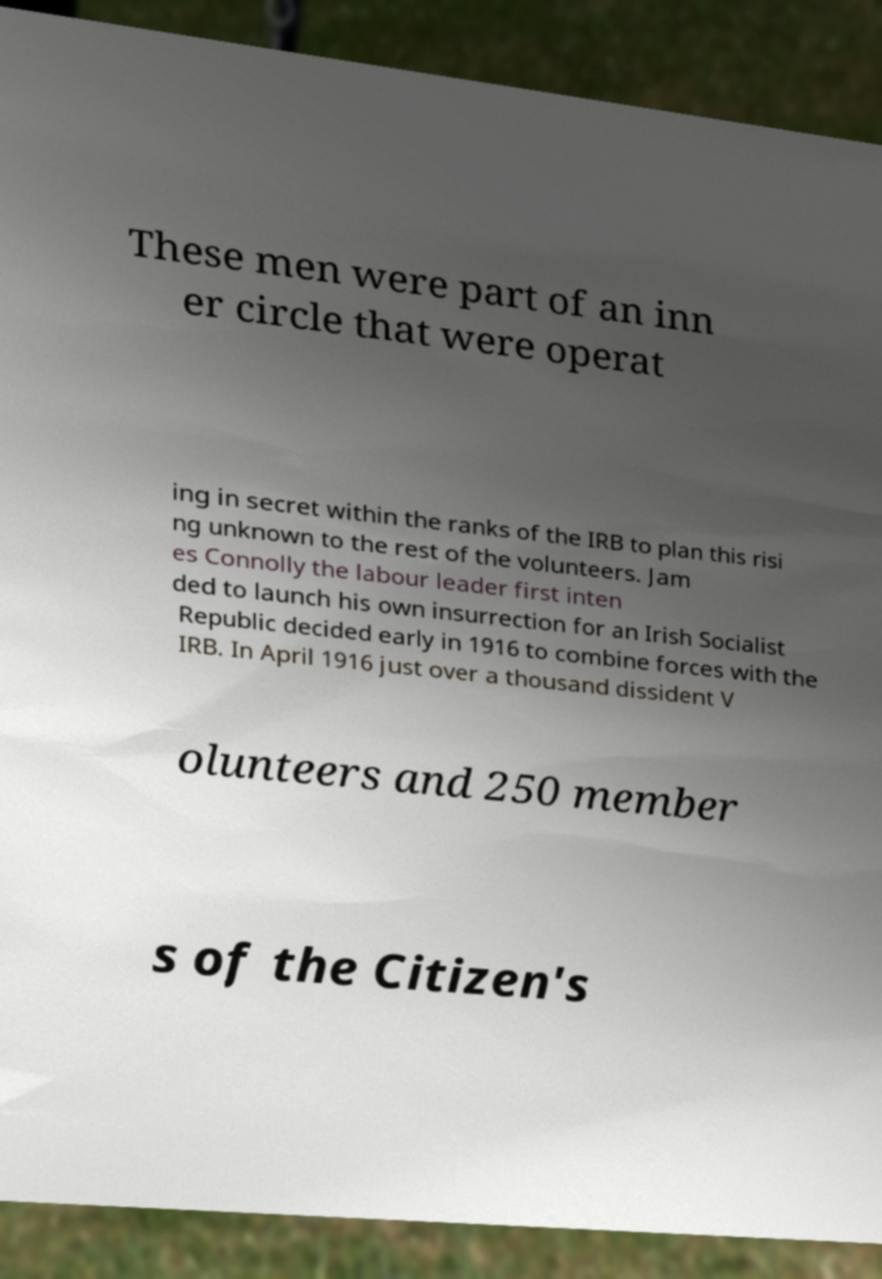Please identify and transcribe the text found in this image. These men were part of an inn er circle that were operat ing in secret within the ranks of the IRB to plan this risi ng unknown to the rest of the volunteers. Jam es Connolly the labour leader first inten ded to launch his own insurrection for an Irish Socialist Republic decided early in 1916 to combine forces with the IRB. In April 1916 just over a thousand dissident V olunteers and 250 member s of the Citizen's 